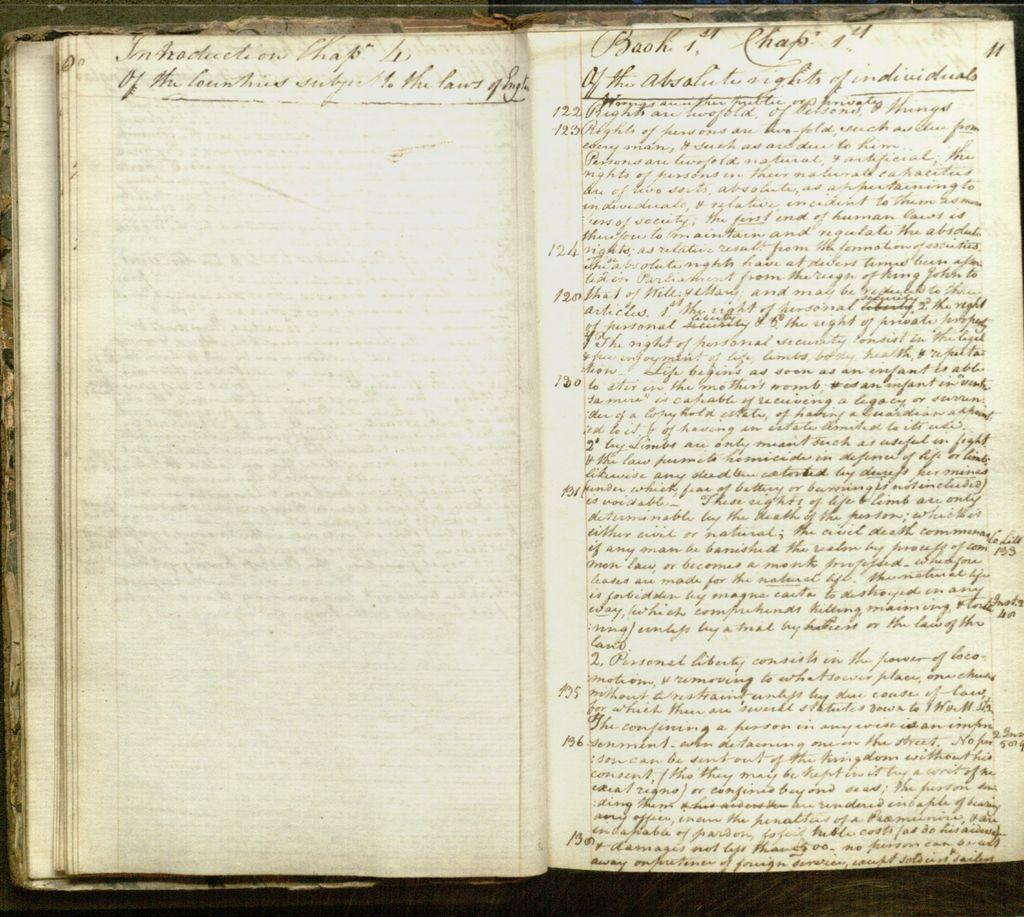<image>
Offer a succinct explanation of the picture presented. A very old book is opened to a page that says introduction chapter on the top left. 